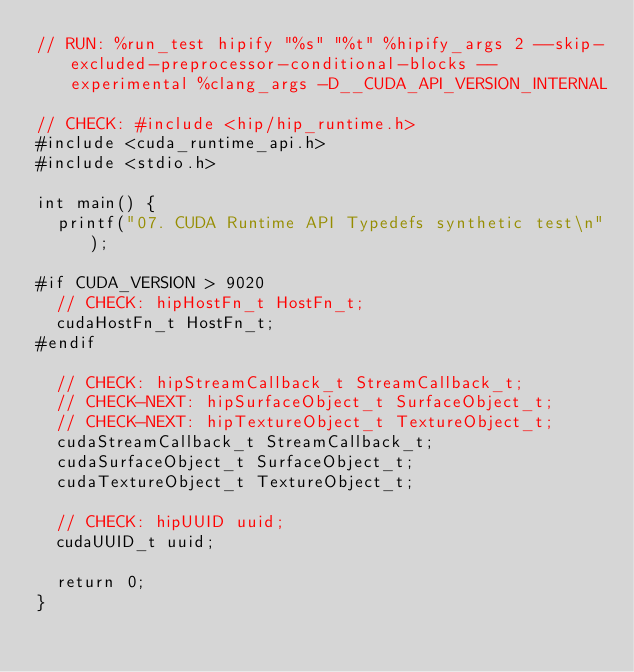Convert code to text. <code><loc_0><loc_0><loc_500><loc_500><_Cuda_>// RUN: %run_test hipify "%s" "%t" %hipify_args 2 --skip-excluded-preprocessor-conditional-blocks --experimental %clang_args -D__CUDA_API_VERSION_INTERNAL

// CHECK: #include <hip/hip_runtime.h>
#include <cuda_runtime_api.h>
#include <stdio.h>

int main() {
  printf("07. CUDA Runtime API Typedefs synthetic test\n");

#if CUDA_VERSION > 9020
  // CHECK: hipHostFn_t HostFn_t;
  cudaHostFn_t HostFn_t;
#endif

  // CHECK: hipStreamCallback_t StreamCallback_t;
  // CHECK-NEXT: hipSurfaceObject_t SurfaceObject_t;
  // CHECK-NEXT: hipTextureObject_t TextureObject_t;
  cudaStreamCallback_t StreamCallback_t;
  cudaSurfaceObject_t SurfaceObject_t;
  cudaTextureObject_t TextureObject_t;

  // CHECK: hipUUID uuid;
  cudaUUID_t uuid;

  return 0;
}
</code> 